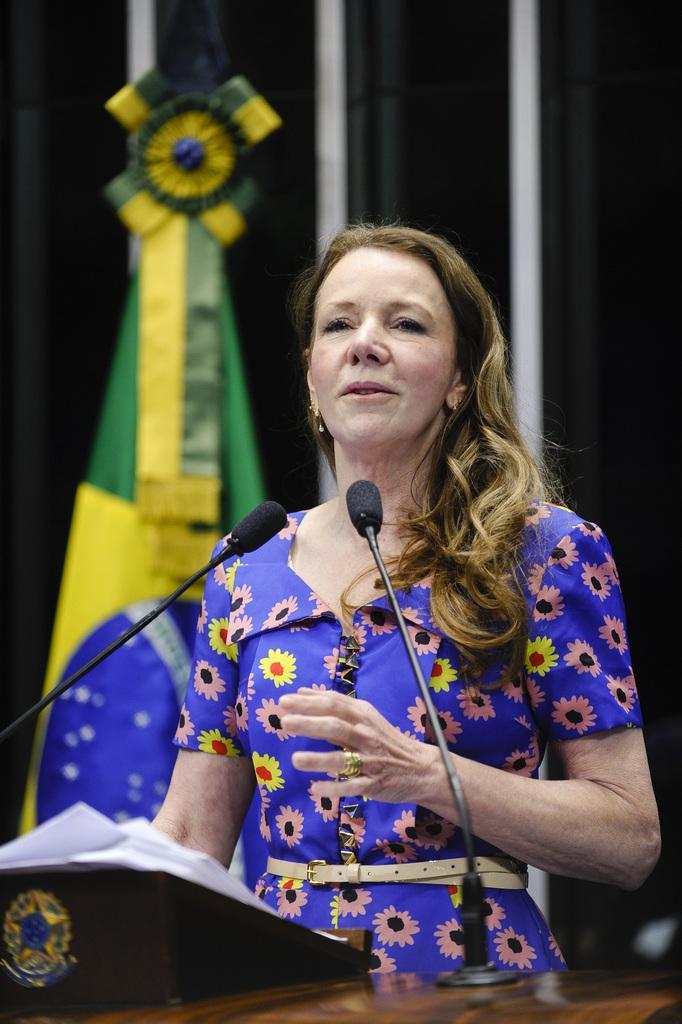In one or two sentences, can you explain what this image depicts? In the picture there is a woman standing in the foreground and she speaking something, in front of the woman there are two mics and some papers, behind her there is a flag. 